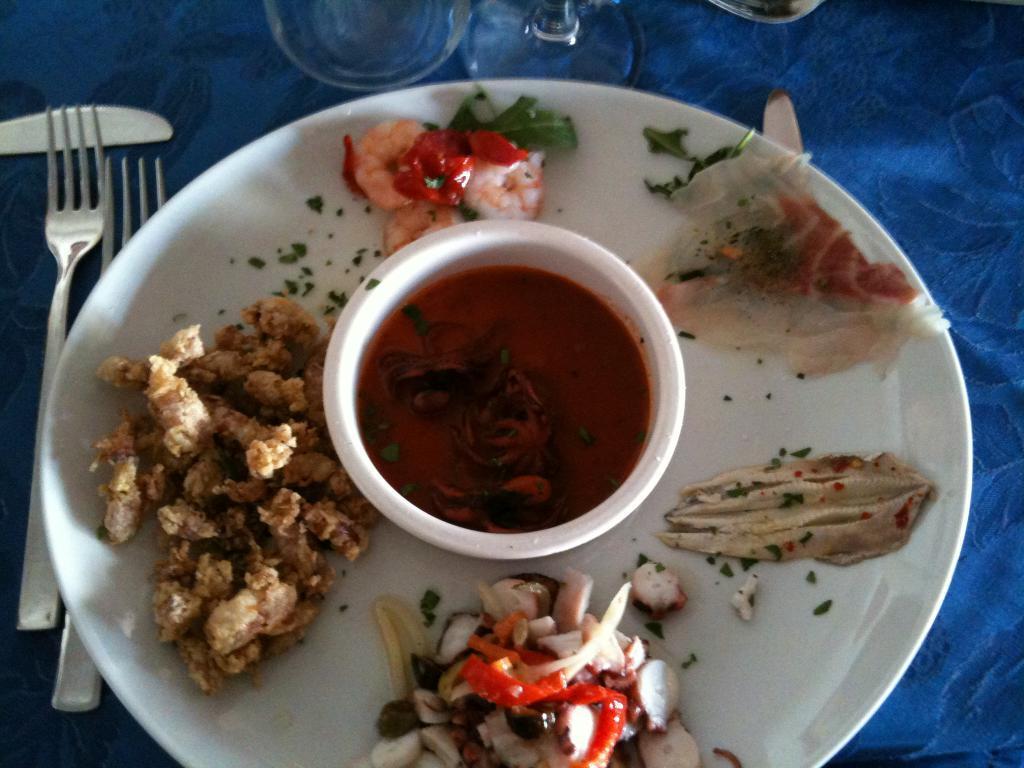Can you describe this image briefly? In this image we can see there is a table. On the table there are some food items placed on a plate, sauce in a bowl, beside that there are two forks and one knife. In front of them there is a glass. 